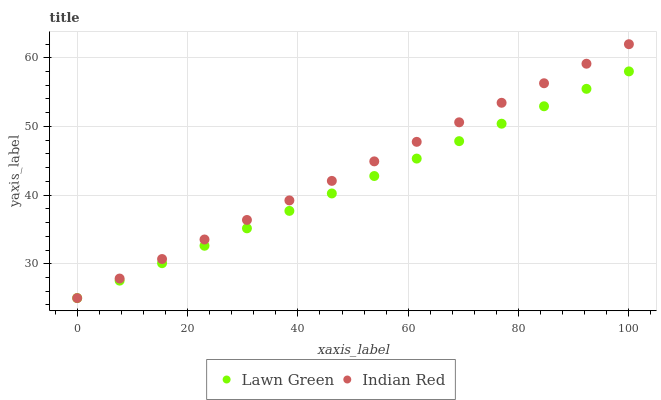Does Lawn Green have the minimum area under the curve?
Answer yes or no. Yes. Does Indian Red have the maximum area under the curve?
Answer yes or no. Yes. Does Indian Red have the minimum area under the curve?
Answer yes or no. No. Is Indian Red the smoothest?
Answer yes or no. Yes. Is Lawn Green the roughest?
Answer yes or no. Yes. Is Indian Red the roughest?
Answer yes or no. No. Does Lawn Green have the lowest value?
Answer yes or no. Yes. Does Indian Red have the highest value?
Answer yes or no. Yes. Does Indian Red intersect Lawn Green?
Answer yes or no. Yes. Is Indian Red less than Lawn Green?
Answer yes or no. No. Is Indian Red greater than Lawn Green?
Answer yes or no. No. 